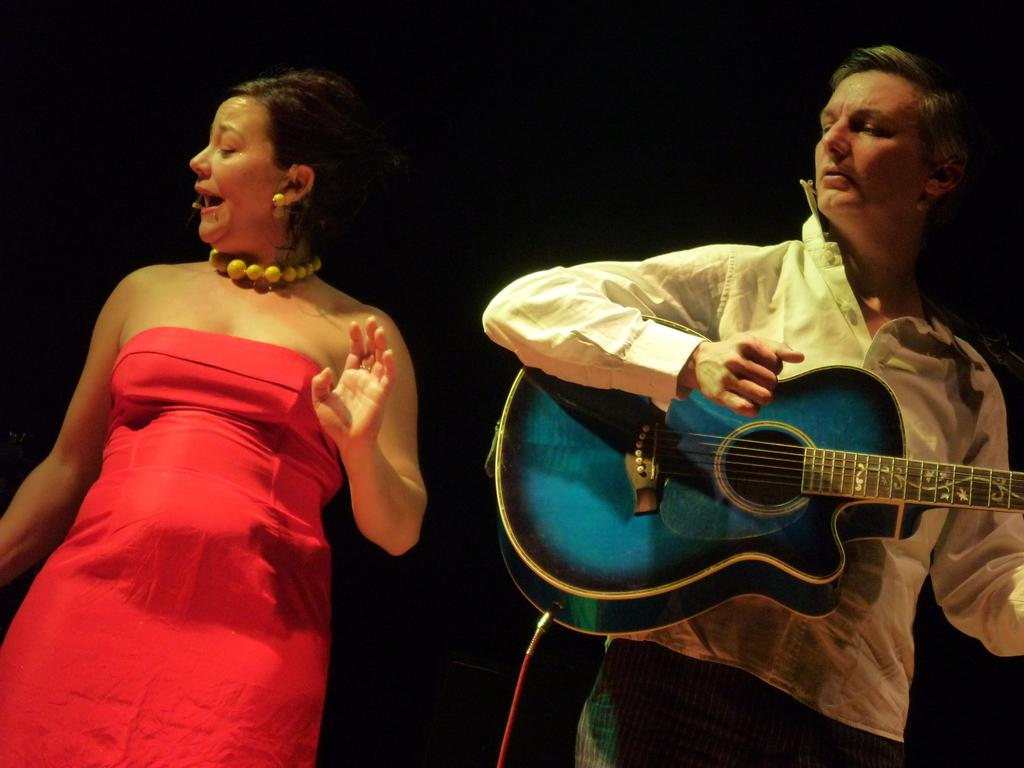Who is the person on the right side of the image? There is a man on the right side of the image. What is the man wearing in the image? The man is wearing a white shirt and trousers. What is the man doing in the image? The man is playing a guitar. Who is the person on the left side of the image? There is a woman on the left side of the image. What is the woman wearing in the image? The woman is wearing a red dress. What is the woman doing in the image? The woman is singing. What season is depicted in the image? The image does not depict a specific season; it only shows a man and a woman engaged in musical activities. 